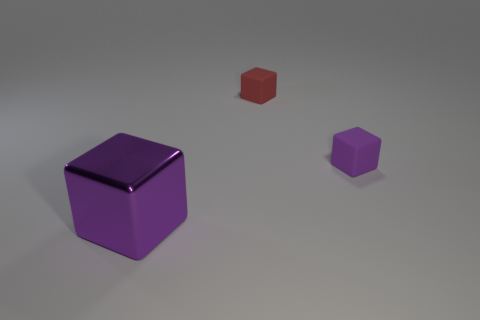Subtract all rubber blocks. How many blocks are left? 1 Subtract 1 blocks. How many blocks are left? 2 Add 1 big blocks. How many objects exist? 4 Subtract all red blocks. How many blocks are left? 2 Subtract 0 cyan spheres. How many objects are left? 3 Subtract all red blocks. Subtract all yellow balls. How many blocks are left? 2 Subtract all red cylinders. How many brown cubes are left? 0 Subtract all purple matte objects. Subtract all small purple rubber cubes. How many objects are left? 1 Add 1 small red rubber cubes. How many small red rubber cubes are left? 2 Add 1 cyan metallic balls. How many cyan metallic balls exist? 1 